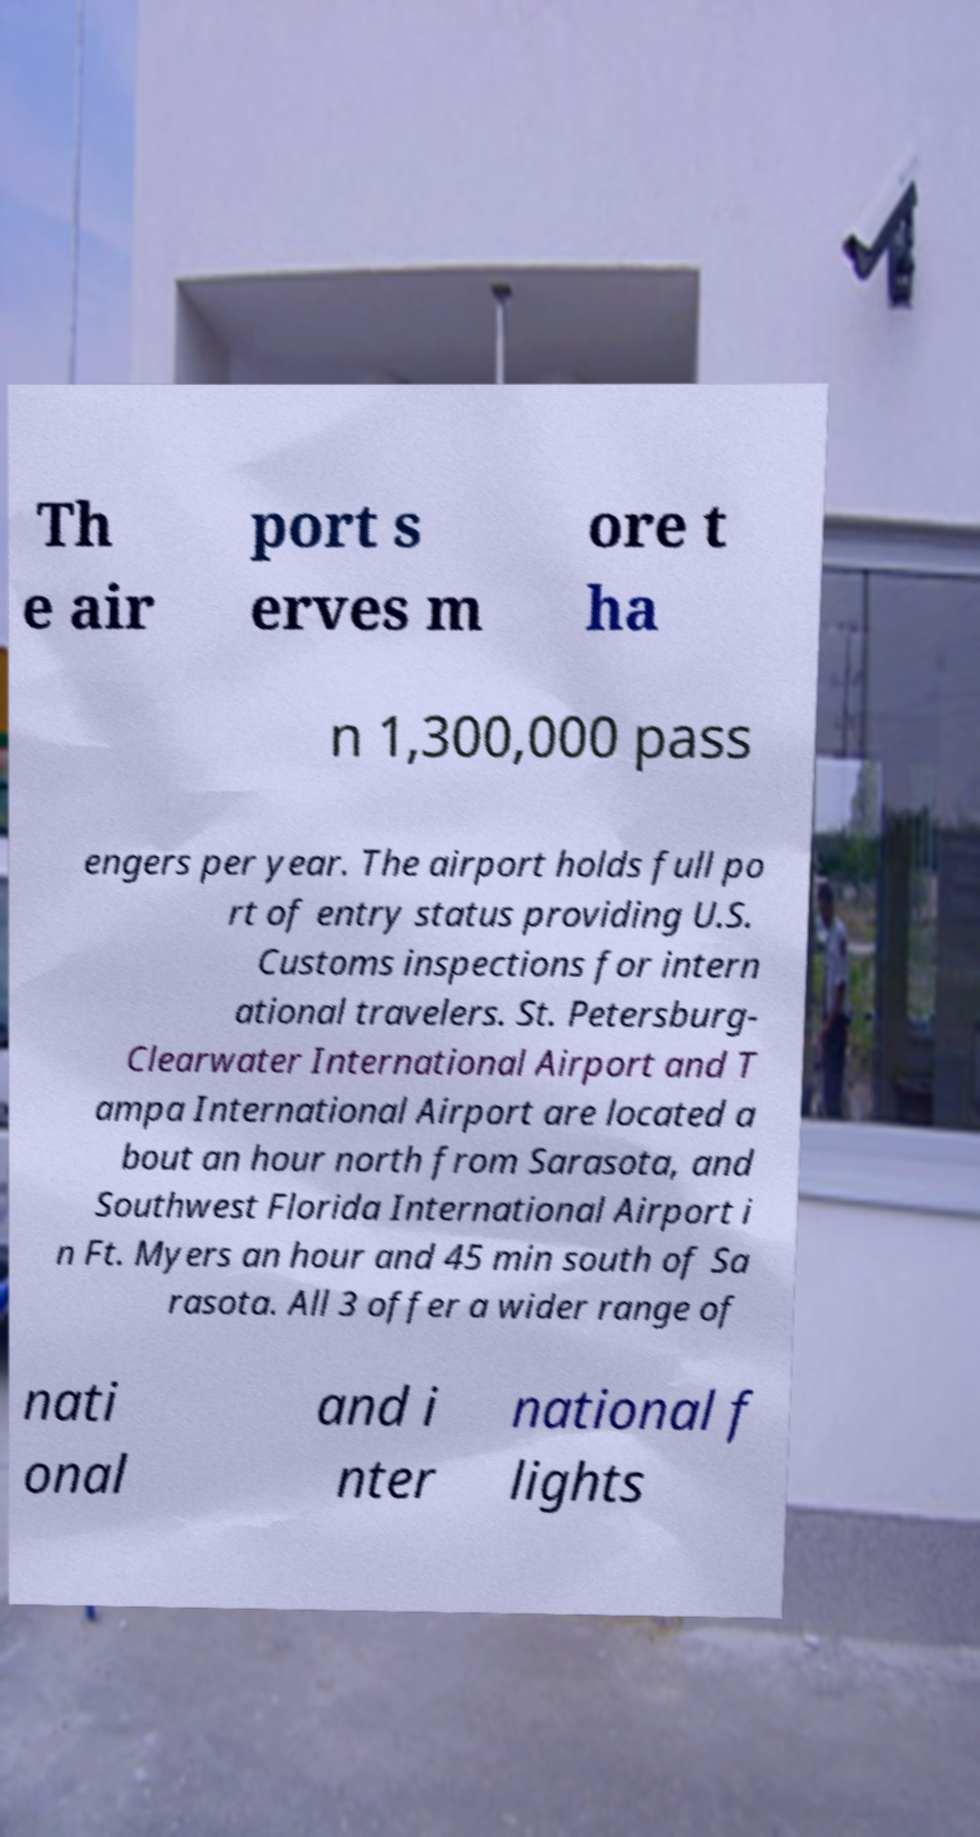Could you assist in decoding the text presented in this image and type it out clearly? Th e air port s erves m ore t ha n 1,300,000 pass engers per year. The airport holds full po rt of entry status providing U.S. Customs inspections for intern ational travelers. St. Petersburg- Clearwater International Airport and T ampa International Airport are located a bout an hour north from Sarasota, and Southwest Florida International Airport i n Ft. Myers an hour and 45 min south of Sa rasota. All 3 offer a wider range of nati onal and i nter national f lights 